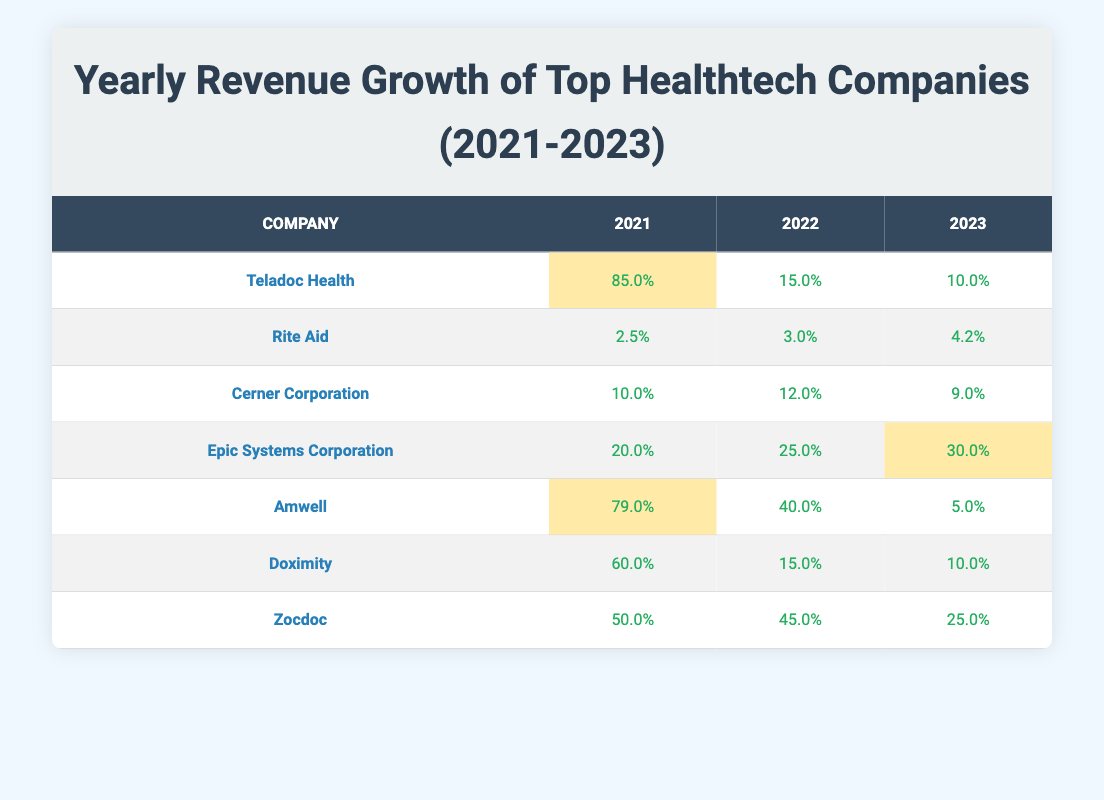What was the revenue growth percentage for Teladoc Health in 2022? The table directly lists the revenue growth percentage for Teladoc Health in 2022 as 15.0%.
Answer: 15.0% Which healthtech company had the highest revenue growth in 2021? By examining the table, Teladoc Health shows the highest revenue growth of 85.0% in 2021 compared to other companies listed.
Answer: Teladoc Health What was the average revenue growth percentage for Epic Systems Corporation over the three years? To find the average, we sum the values: (20.0 + 25.0 + 30.0) = 75.0, and then divide by the number of years (3), so 75.0 / 3 = 25.0%.
Answer: 25.0% Did Doximity experience any decline in revenue growth from 2021 to 2023? The table shows 60.0% in 2021, down to 15.0% in 2022, and then further down to 10.0% in 2023, indicating a decline over the years.
Answer: Yes What is the total revenue growth percentage for Amwell from 2021 to 2023? For Amwell: 79.0% + 40.0% + 5.0% = 124.0%. So, the total revenue growth percentage from 2021 to 2023 is 124.0%.
Answer: 124.0% Which company had consistent growth over the years with no decline? By reviewing the table, Epic Systems Corporation shows no decline in any year (20.0%, 25.0%, 30.0%).
Answer: Epic Systems Corporation In which year did Zocdoc experience its lowest revenue growth? Looking at the Zocdoc row in the table, the lowest revenue growth shown is 25.0% in 2023.
Answer: 2023 What is the difference in revenue growth percentage for Cerner Corporation between 2021 and 2022? Cerner Corporation's growth was 12.0% in 2022 compared to 10.0% in 2021, making the difference 12.0% - 10.0% = 2.0%.
Answer: 2.0% Which company had the largest drop in revenue growth from 2021 to 2023? Reviewing the figures, Amwell's growth dropped from 79.0% in 2021 to 5.0% in 2023, resulting in a decline of 74.0%.
Answer: Amwell What percentage of growth did Rite Aid achieve in 2022 compared to 2021? Rite Aid showed 3.0% in 2022 and 2.5% in 2021, which is an increase of 3.0% - 2.5% = 0.5%.
Answer: 0.5% 